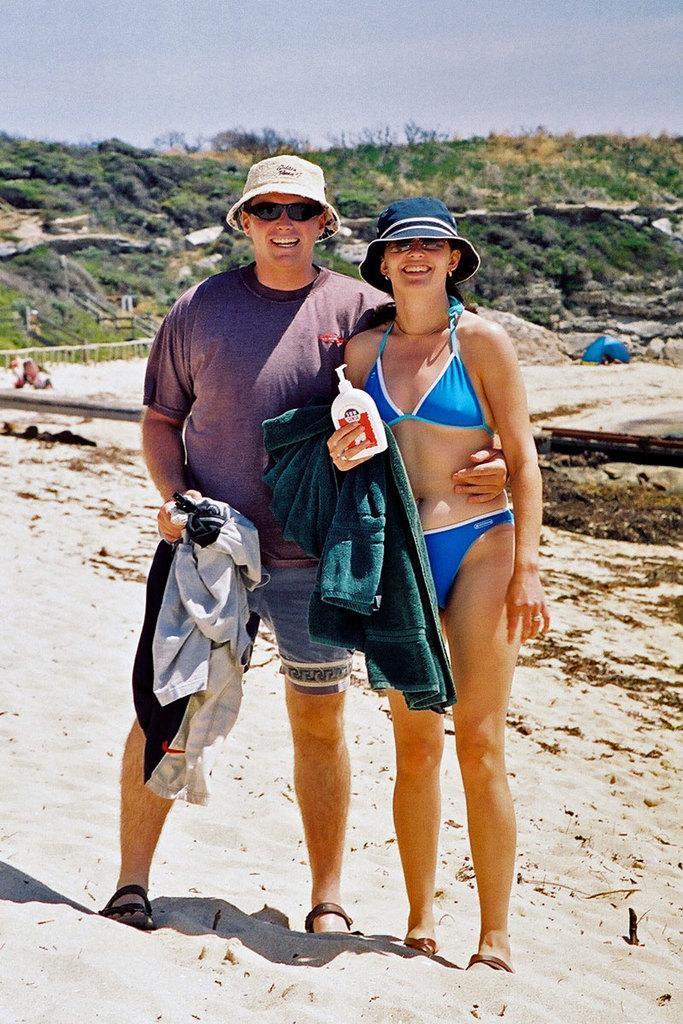Please provide a concise description of this image. In this picture I can see a man and a woman standing and smiling, there is sand, there is a blue color tint, there are trees, and in the background there is the sky. 